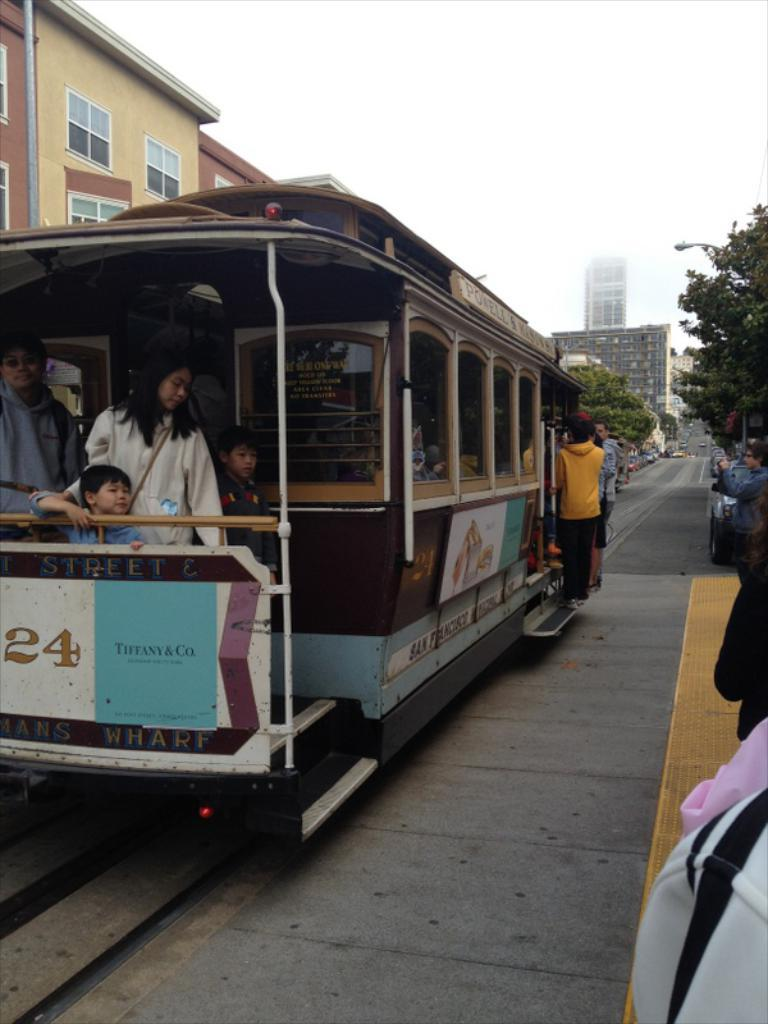What can be seen inside the bus in the image? There are people in the bus. What is visible in the background of the image? There are trees, buildings, and the sky visible in the background of the image. What other objects can be seen in the background of the image? There are other objects in the background of the image. What type of collar can be seen on the art in the image? There is no art or collar present in the image. 